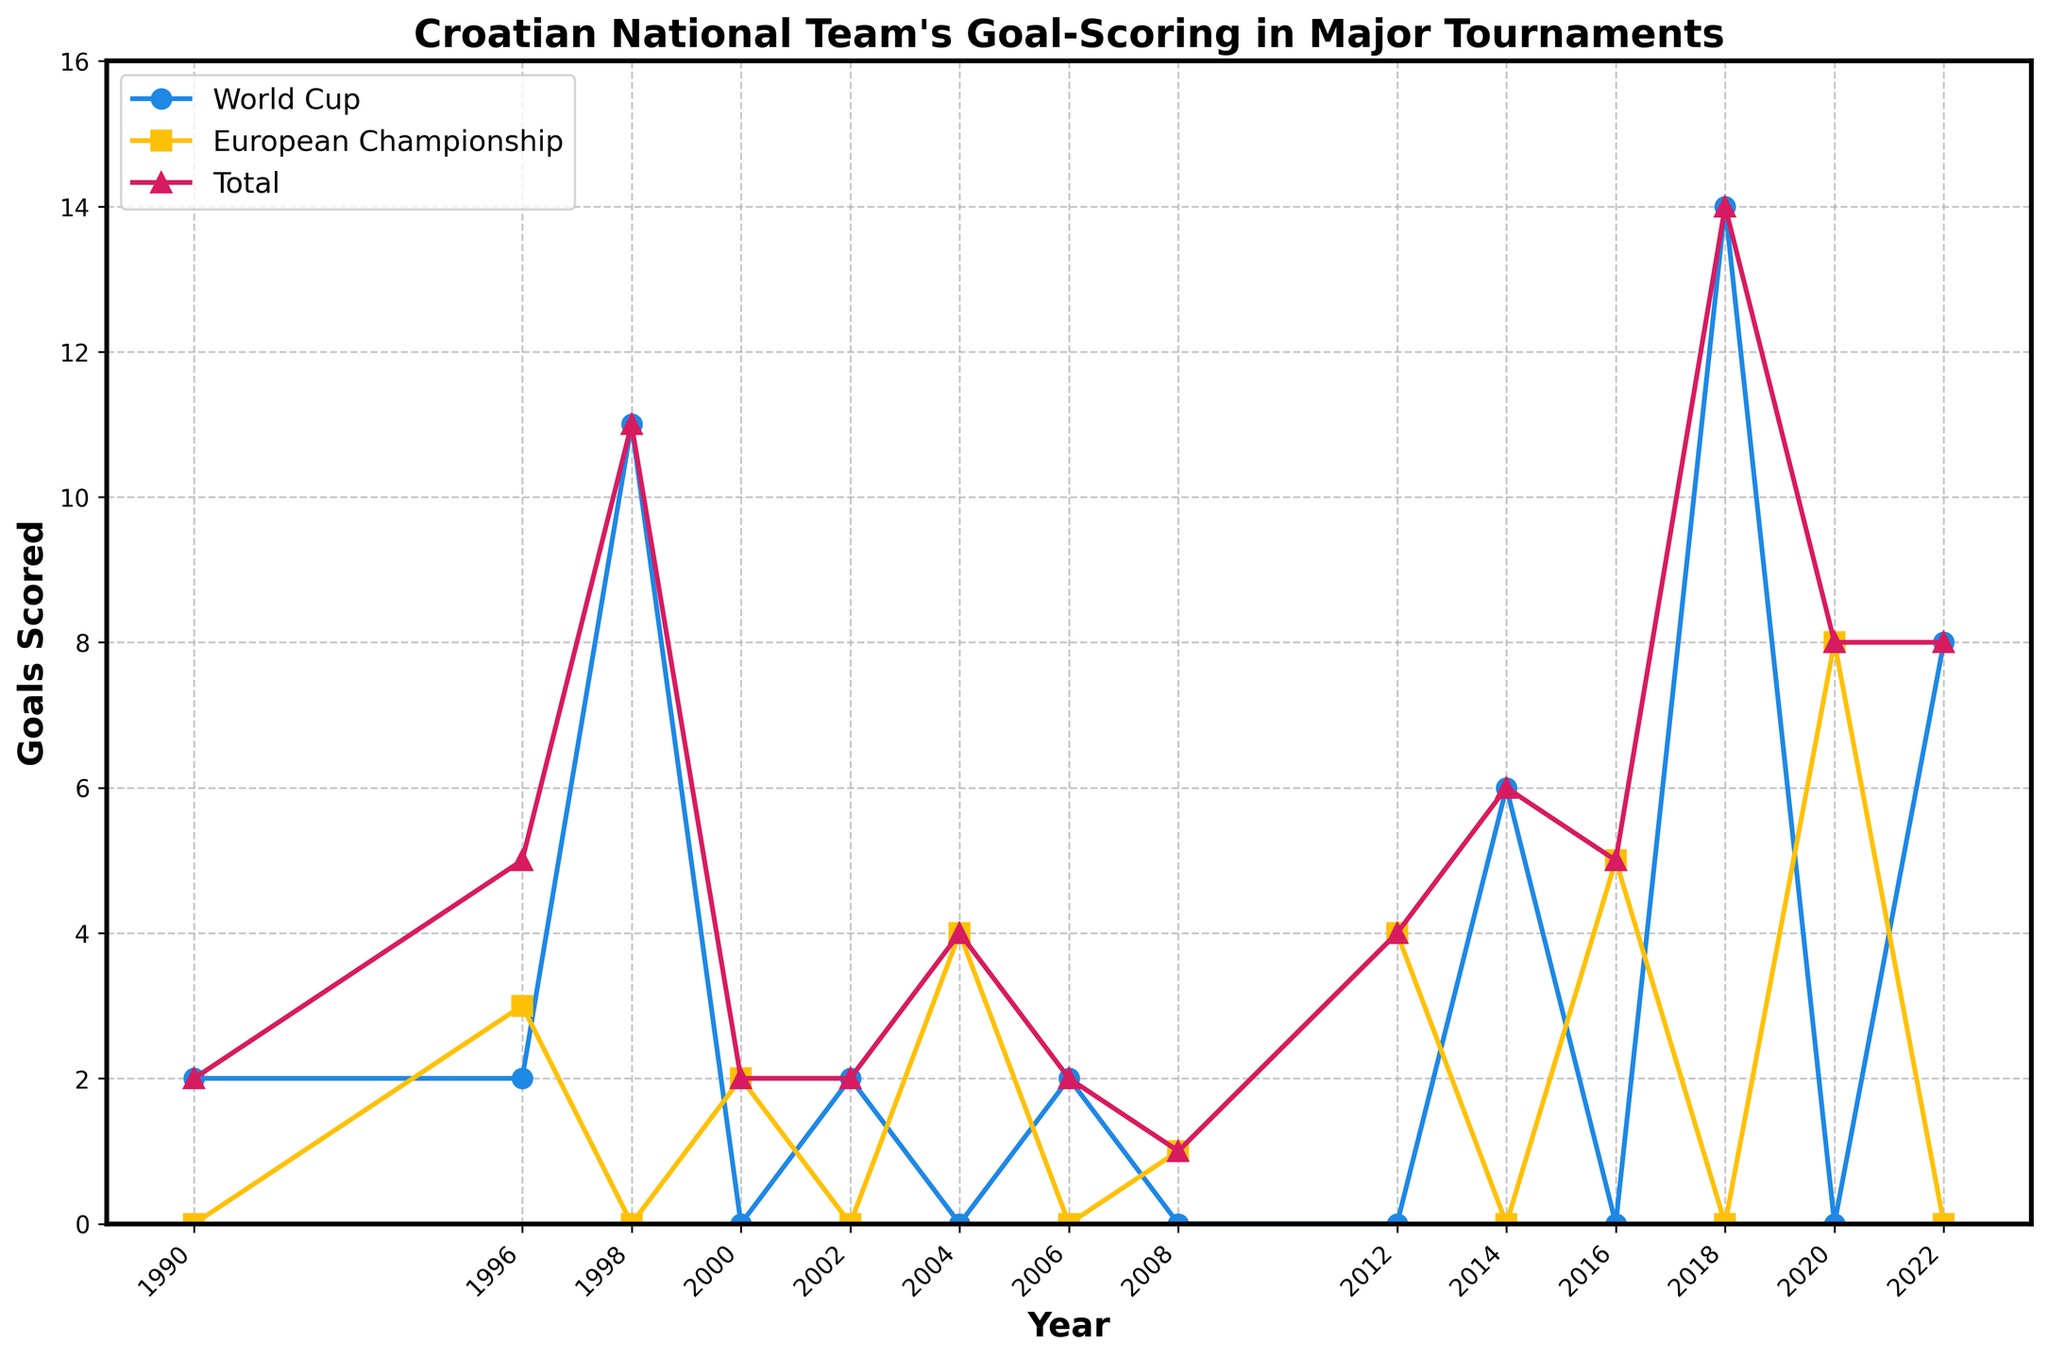What is the total number of goals scored by the Croatian national team in the World Cup in 2018? The 2018 World Cup goals can be seen on the figure where the year is 2018. According to the data, the total number of World Cup goals scored in 2018 is 14.
Answer: 14 How many more goals were scored in the World Cup compared to the European Championship in 2022? Identify the number of goals scored in both tournaments in 2022. For the World Cup, 8 goals were scored and for the European Championship, 0 goals were scored. The difference is 8 - 0.
Answer: 8 In which year did the Croatian national team score the highest number of total tournament goals? By checking each data point for the highest value on the "Total" line, 2018 stands out with 14 goals.
Answer: 2018 What is the average number of goals scored in European Championships between 2000 and 2016? Sum the goals scored in European Championships for the years 2000, 2004, 2008, 2012, and 2016, then divide by the number of European Championships (2 + 4 + 1 + 4 + 5). The average is (2 + 4 + 1 + 4 + 5) / 5.
Answer: 3.2 In which year was there the smallest difference between the World Cup goals and European Championship goals? Compare the differences for each year and find the smallest difference. The smallest difference of 0 goals occurs in 1996 and 2008.
Answer: 1996 and 2008 What was the total number of goals scored in all major tournaments in 2014? Identify the data point where the year is 2014. According to the data, the total number of goals scored in 2014 is 6.
Answer: 6 Which tournament had a higher number of goals scored in 2002, and by how much? Compare the goals scored in the World Cup (2) versus the European Championship (0) for 2002. The World Cup goals exceed the European Championship goals by 2 - 0.
Answer: World Cup by 2 Calculate the total number of World Cup goals and the total number of European Championship goals scored from 1990 to 2022. Sum all the World Cup goals (2 + 2 + 11 + 0 + 2 + 0 + 2 + 0 + 0 + 6 + 0 + 14 + 0 + 8) and all the European Championship goals (0 + 3 + 0 + 2 + 0 + 4 + 0 + 1 + 4 + 0 + 5 + 0 + 8). The total for the World Cup is 47, and for the European Championship, it is 27.
Answer: World Cup: 47, European Championship: 27 Which year(s) had an equal number of goals scored in both the World Cup and European Championship? Identify the years where the same number of goals is scored in both tournaments. In 1996, 2 World Cup goals equals 2 European Championship goals; in 2000, 0 World Cup goals equals 2 European Championship goals; and in 2000, 0 World Cup goals equals 2 European Championship goals.
Answer: 1996 and 2000 From which tournament do most of the goals come in 1998, and by how many goals? Identify the number of goals from both tournaments in 1998. There were 11 World Cup goals and 0 European Championship goals. The World Cup had 11 more goals.
Answer: World Cup by 11 